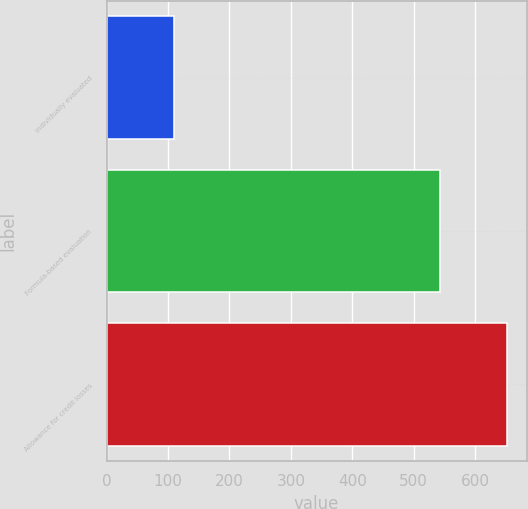<chart> <loc_0><loc_0><loc_500><loc_500><bar_chart><fcel>Individually evaluated<fcel>Formula-based evaluation<fcel>Allowance for credit losses<nl><fcel>109<fcel>542<fcel>651<nl></chart> 